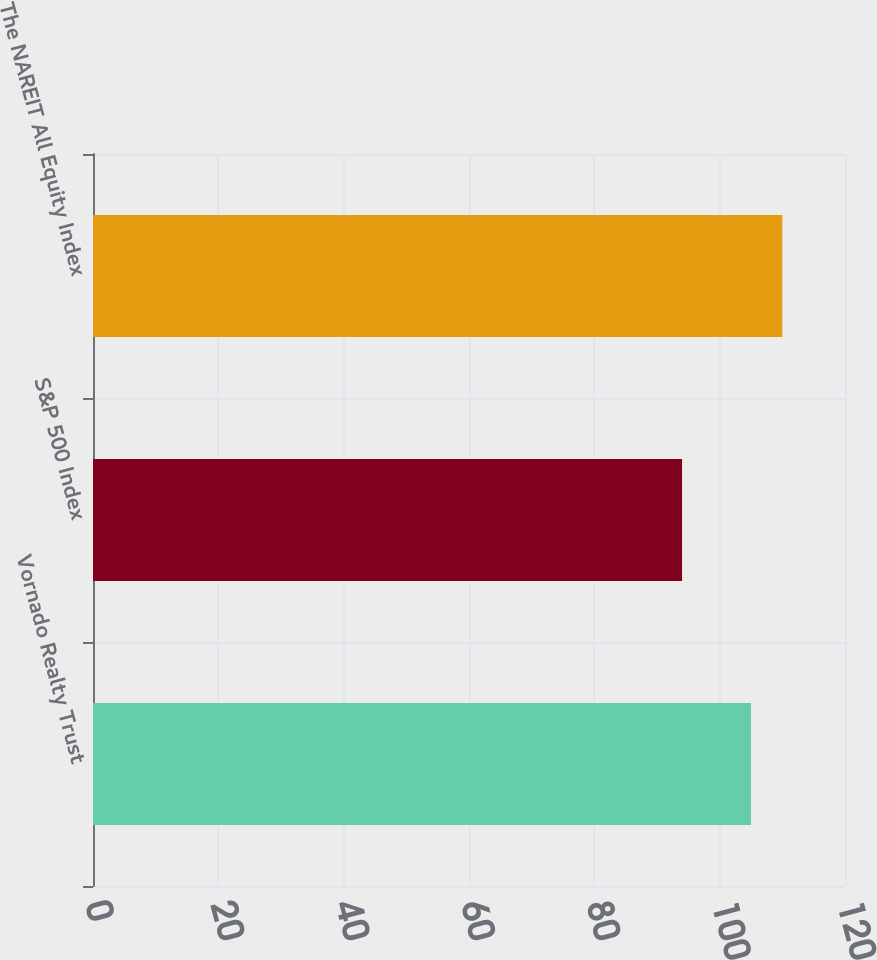Convert chart to OTSL. <chart><loc_0><loc_0><loc_500><loc_500><bar_chart><fcel>Vornado Realty Trust<fcel>S&P 500 Index<fcel>The NAREIT All Equity Index<nl><fcel>105<fcel>94<fcel>110<nl></chart> 